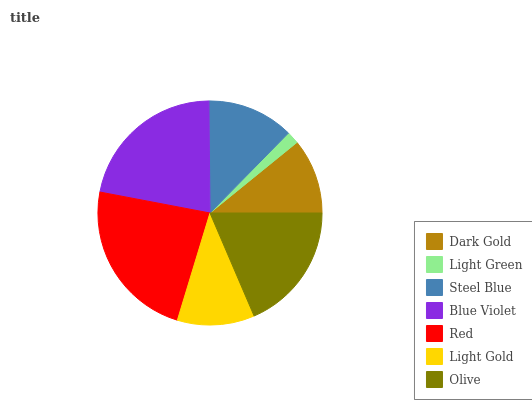Is Light Green the minimum?
Answer yes or no. Yes. Is Red the maximum?
Answer yes or no. Yes. Is Steel Blue the minimum?
Answer yes or no. No. Is Steel Blue the maximum?
Answer yes or no. No. Is Steel Blue greater than Light Green?
Answer yes or no. Yes. Is Light Green less than Steel Blue?
Answer yes or no. Yes. Is Light Green greater than Steel Blue?
Answer yes or no. No. Is Steel Blue less than Light Green?
Answer yes or no. No. Is Steel Blue the high median?
Answer yes or no. Yes. Is Steel Blue the low median?
Answer yes or no. Yes. Is Dark Gold the high median?
Answer yes or no. No. Is Blue Violet the low median?
Answer yes or no. No. 